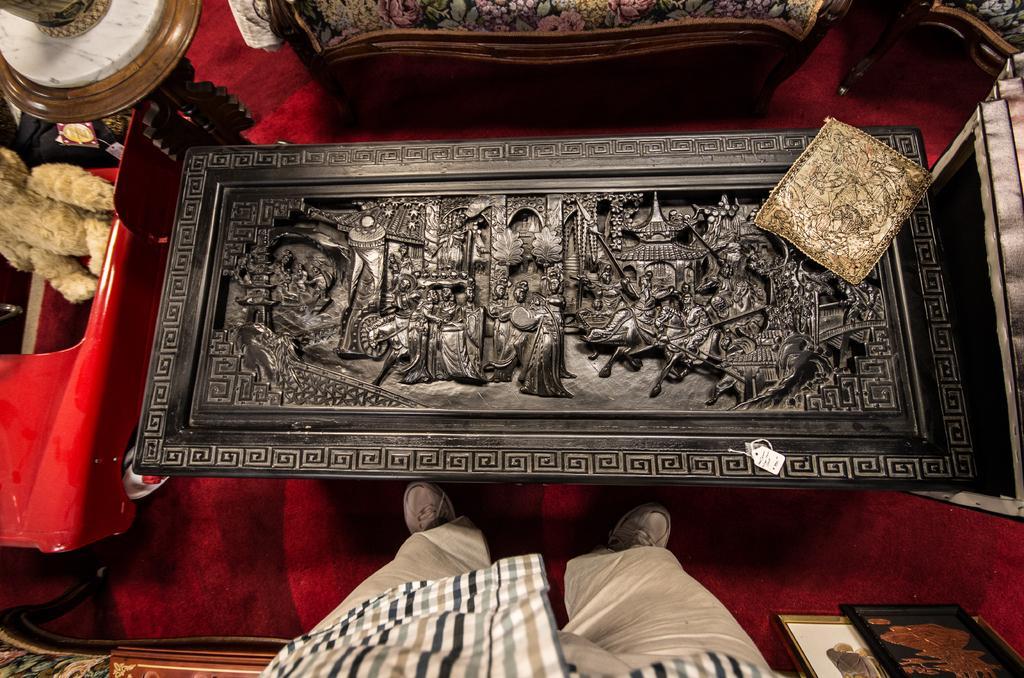How would you summarize this image in a sentence or two? In this image I can see a table. There are some carvings on it. At the bottom I can see a person standing. I can see two chairs. There is a red carpet on the floor. 